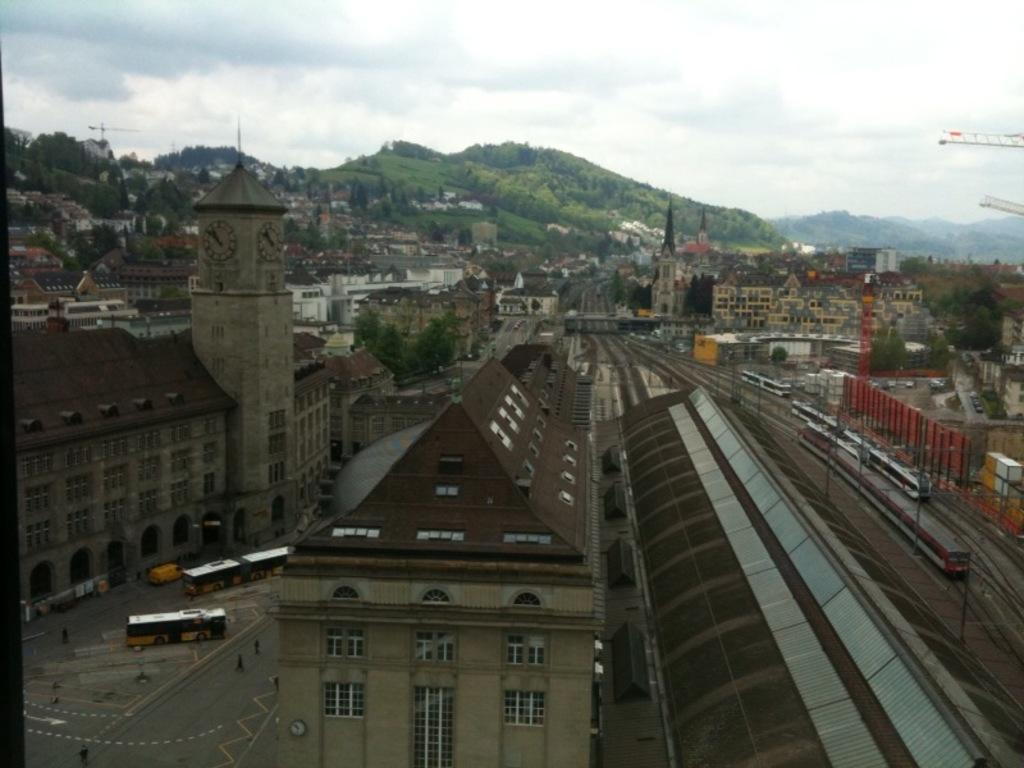In one or two sentences, can you explain what this image depicts? In this image there are few buildings, few vehicles and people on the road, few trains on the tracks, a clock tower, cranes and few mountains covered with trees and plants. 